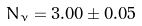Convert formula to latex. <formula><loc_0><loc_0><loc_500><loc_500>N _ { \nu } = 3 . 0 0 \pm 0 . 0 5</formula> 